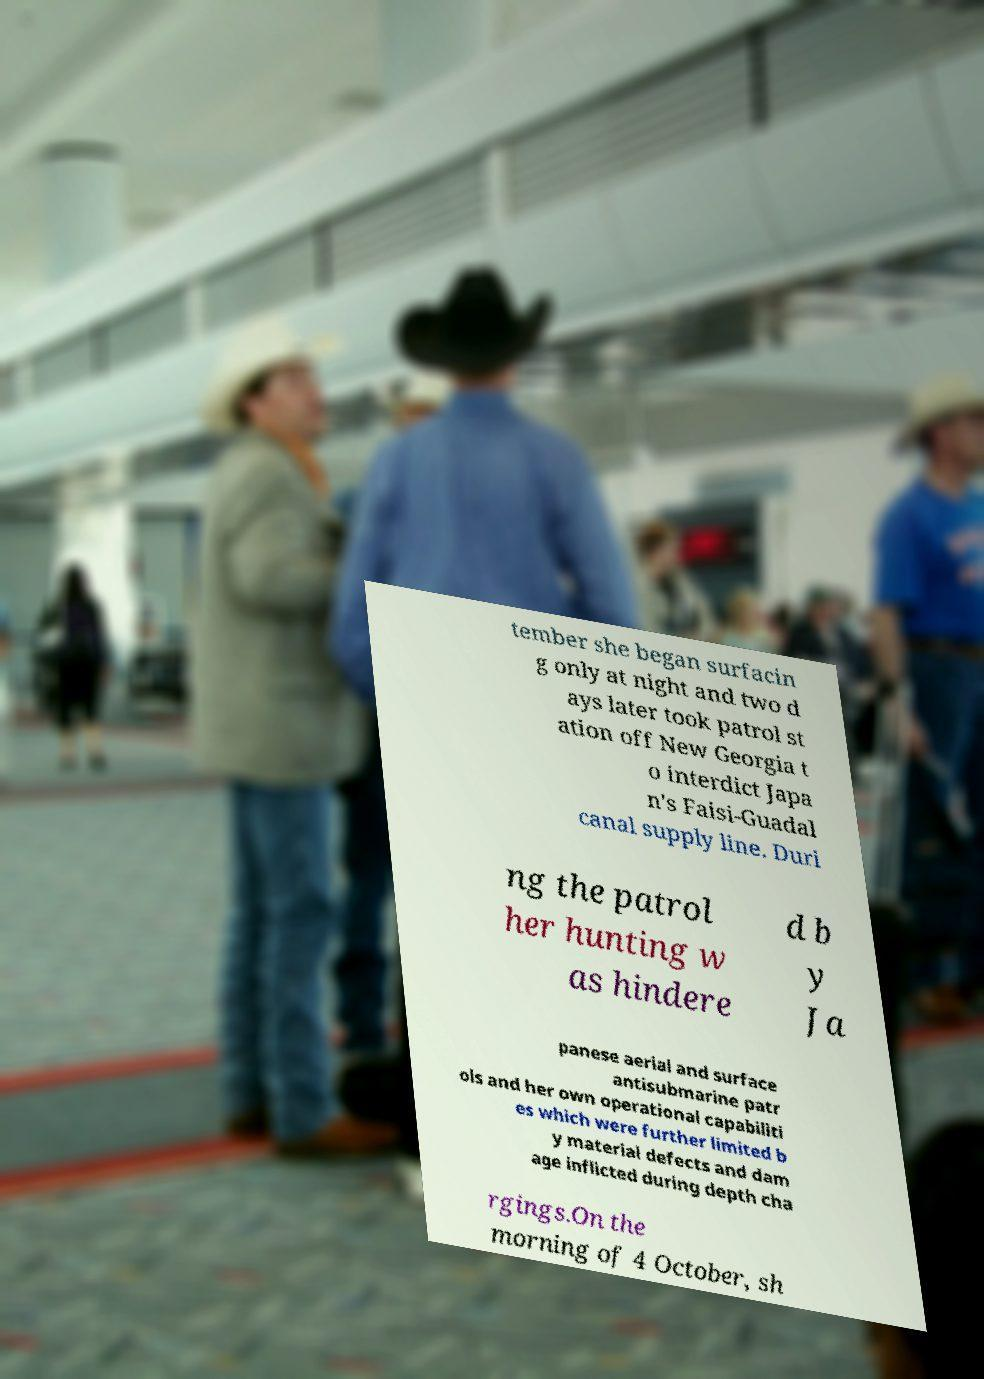Please identify and transcribe the text found in this image. tember she began surfacin g only at night and two d ays later took patrol st ation off New Georgia t o interdict Japa n's Faisi-Guadal canal supply line. Duri ng the patrol her hunting w as hindere d b y Ja panese aerial and surface antisubmarine patr ols and her own operational capabiliti es which were further limited b y material defects and dam age inflicted during depth cha rgings.On the morning of 4 October, sh 